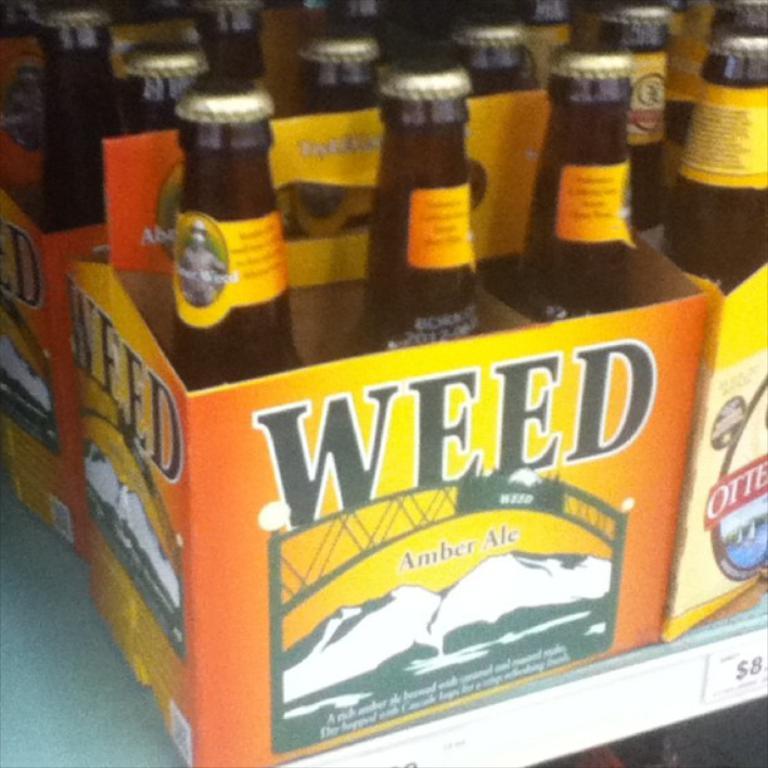What brand of beer is on the left?
Your answer should be compact. Weed. What kind of ale is this?
Provide a short and direct response. Amber ale. 